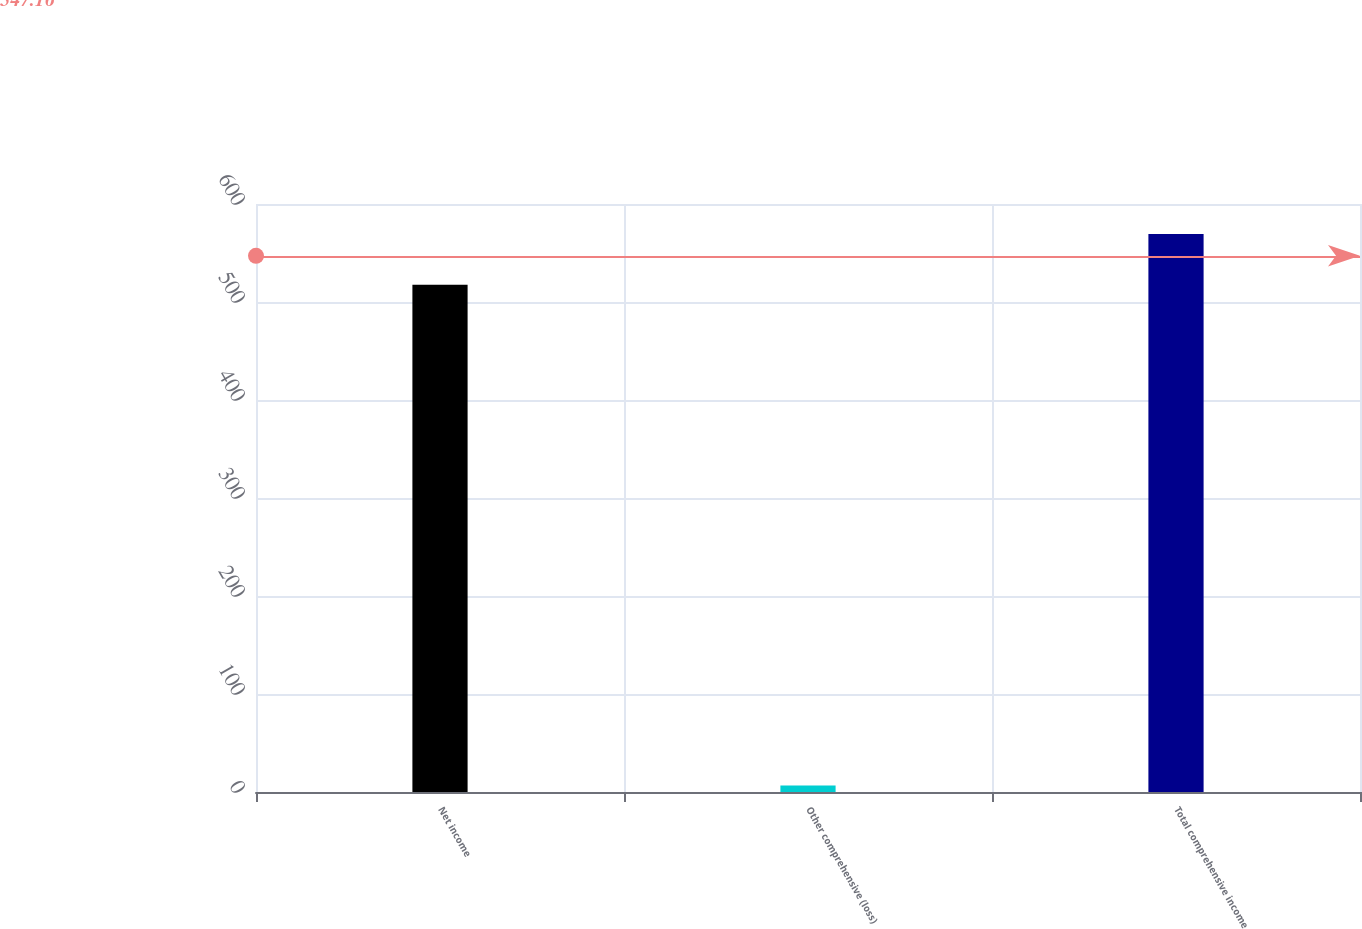Convert chart to OTSL. <chart><loc_0><loc_0><loc_500><loc_500><bar_chart><fcel>Net income<fcel>Other comprehensive (loss)<fcel>Total comprehensive income<nl><fcel>517.6<fcel>6.6<fcel>569.36<nl></chart> 